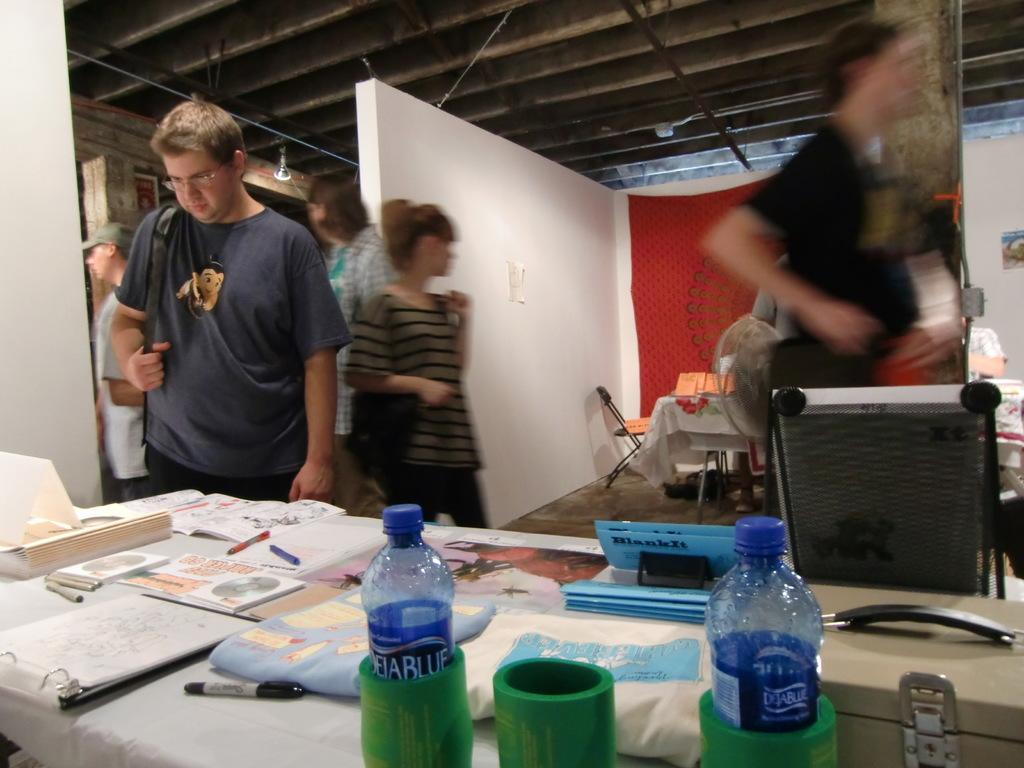<image>
Render a clear and concise summary of the photo. Bottles of Deja Blue are on a table with other items. 